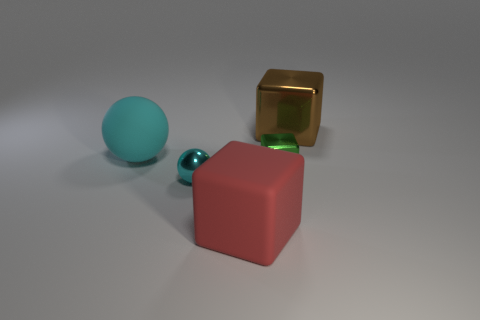Subtract all metal cubes. How many cubes are left? 1 Add 3 large red rubber blocks. How many objects exist? 8 Subtract all green cubes. How many cubes are left? 2 Subtract all blocks. How many objects are left? 2 Subtract all purple blocks. Subtract all gray cylinders. How many blocks are left? 3 Add 3 large rubber objects. How many large rubber objects exist? 5 Subtract 0 gray cylinders. How many objects are left? 5 Subtract all cyan metal objects. Subtract all big metallic blocks. How many objects are left? 3 Add 3 red things. How many red things are left? 4 